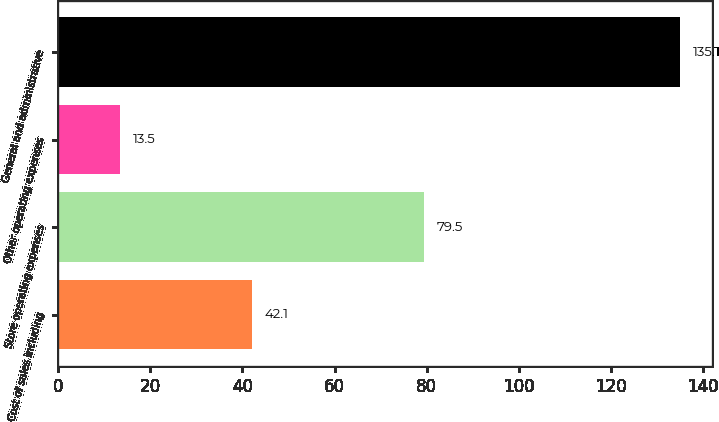Convert chart to OTSL. <chart><loc_0><loc_0><loc_500><loc_500><bar_chart><fcel>Cost of sales including<fcel>Store operating expenses<fcel>Other operating expenses<fcel>General and administrative<nl><fcel>42.1<fcel>79.5<fcel>13.5<fcel>135.1<nl></chart> 